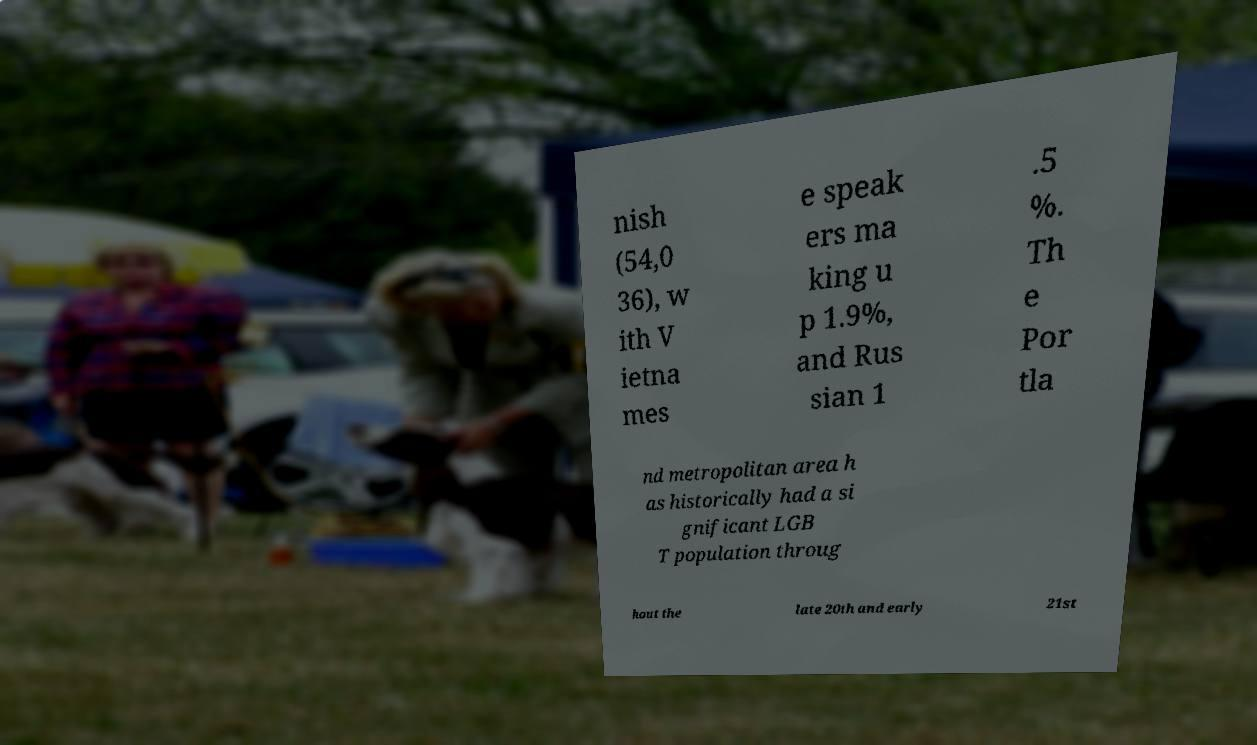For documentation purposes, I need the text within this image transcribed. Could you provide that? nish (54,0 36), w ith V ietna mes e speak ers ma king u p 1.9%, and Rus sian 1 .5 %. Th e Por tla nd metropolitan area h as historically had a si gnificant LGB T population throug hout the late 20th and early 21st 